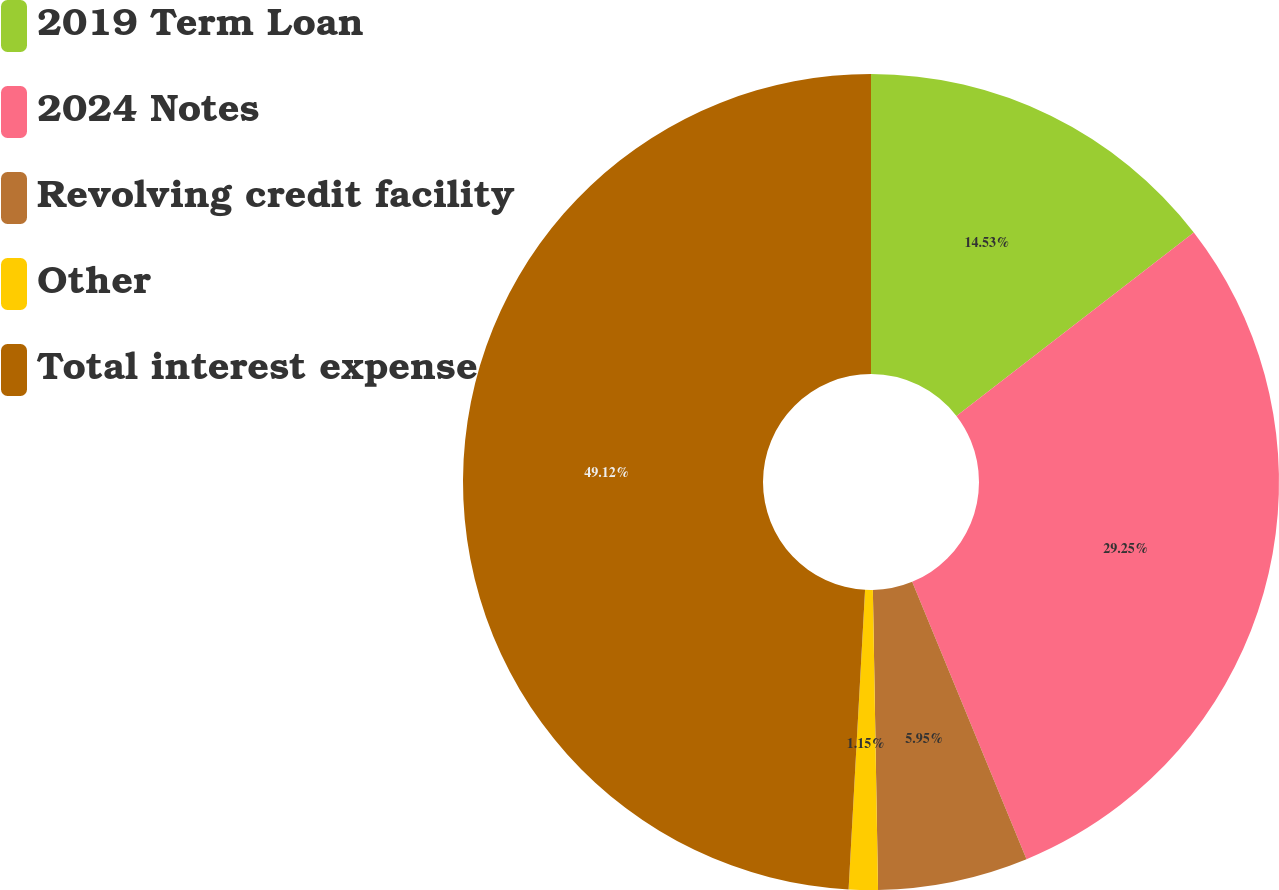Convert chart. <chart><loc_0><loc_0><loc_500><loc_500><pie_chart><fcel>2019 Term Loan<fcel>2024 Notes<fcel>Revolving credit facility<fcel>Other<fcel>Total interest expense<nl><fcel>14.53%<fcel>29.25%<fcel>5.95%<fcel>1.15%<fcel>49.13%<nl></chart> 